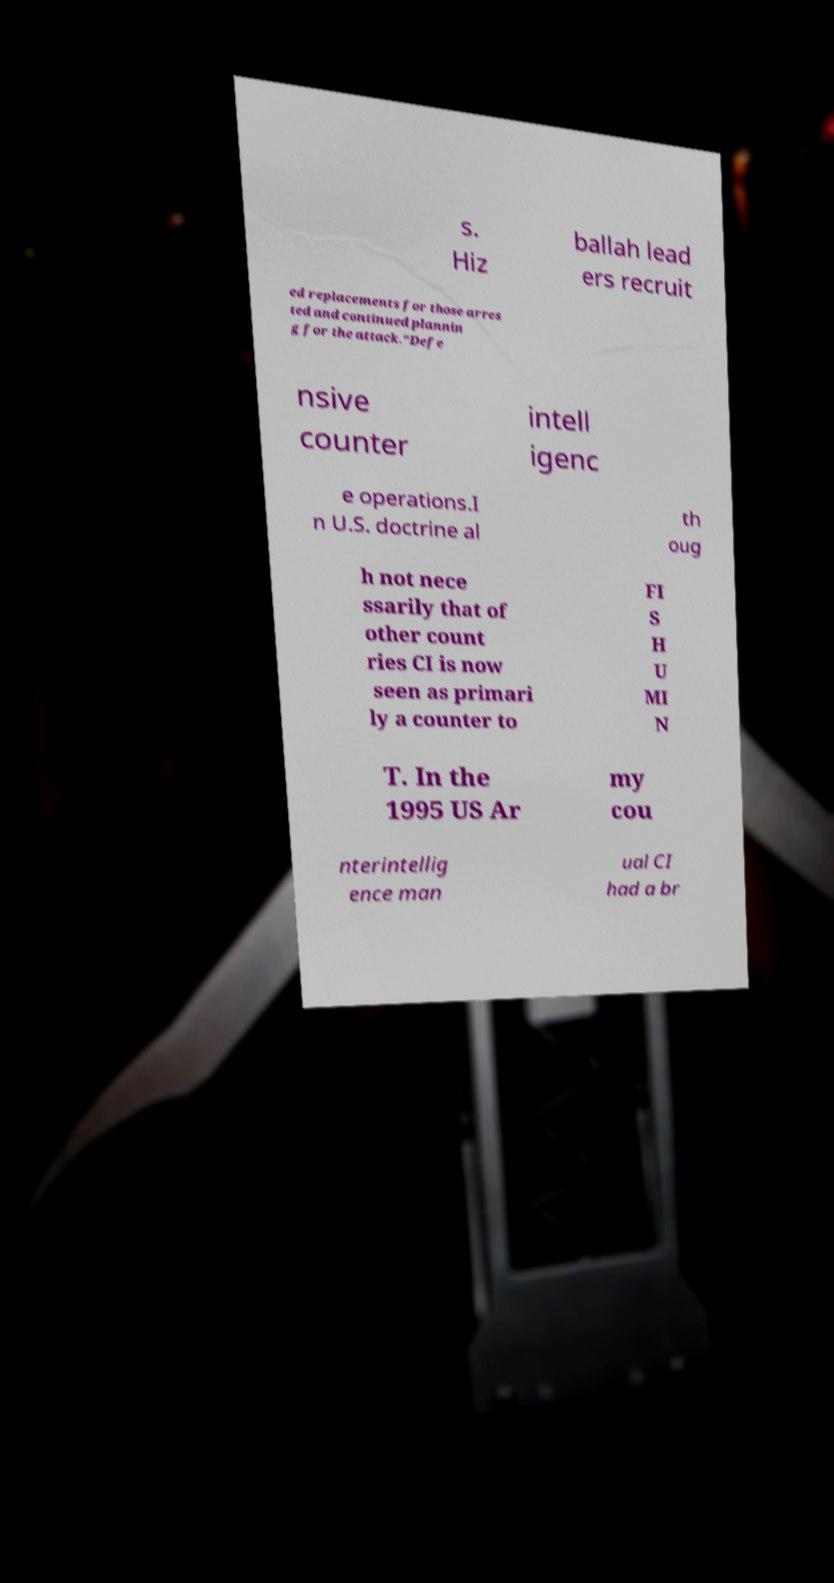Please identify and transcribe the text found in this image. s. Hiz ballah lead ers recruit ed replacements for those arres ted and continued plannin g for the attack."Defe nsive counter intell igenc e operations.I n U.S. doctrine al th oug h not nece ssarily that of other count ries CI is now seen as primari ly a counter to FI S H U MI N T. In the 1995 US Ar my cou nterintellig ence man ual CI had a br 